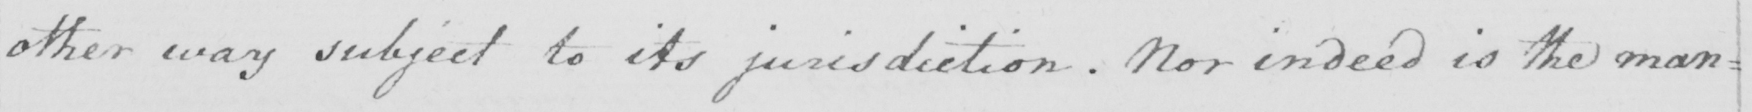Please provide the text content of this handwritten line. other way subject to its jurisdiction . Nor indeed is the man= 